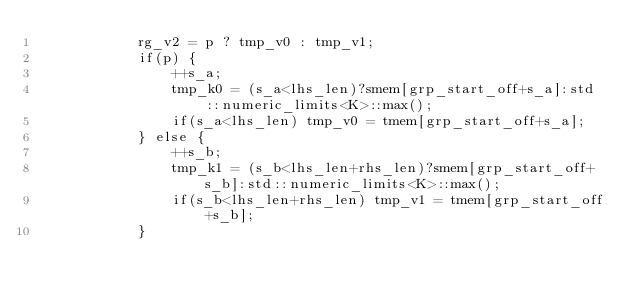<code> <loc_0><loc_0><loc_500><loc_500><_Cuda_>            rg_v2 = p ? tmp_v0 : tmp_v1;
            if(p) {
                ++s_a;
                tmp_k0 = (s_a<lhs_len)?smem[grp_start_off+s_a]:std::numeric_limits<K>::max();
                if(s_a<lhs_len) tmp_v0 = tmem[grp_start_off+s_a];
            } else {
                ++s_b;
                tmp_k1 = (s_b<lhs_len+rhs_len)?smem[grp_start_off+s_b]:std::numeric_limits<K>::max();
                if(s_b<lhs_len+rhs_len) tmp_v1 = tmem[grp_start_off+s_b];
            }</code> 